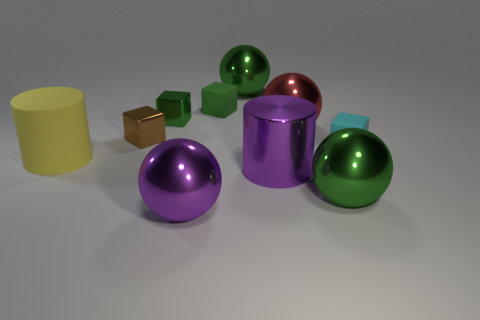Are there any patterns or consistencies in the arrangement of the objects? The objects appear to be arranged without a specific pattern. However, they are grouped by shape - cylinders are together, and so are the spheres and cubes. The arrangement seems random rather than orderly. How does the grouping by shape affect the overall composition of the image? The grouping by shape creates a visual distinction between different geometric forms, allowing us to compare their characteristics such as color, size, and reflective qualities. It gives the image a structured feel despite the random placement of the groups. 